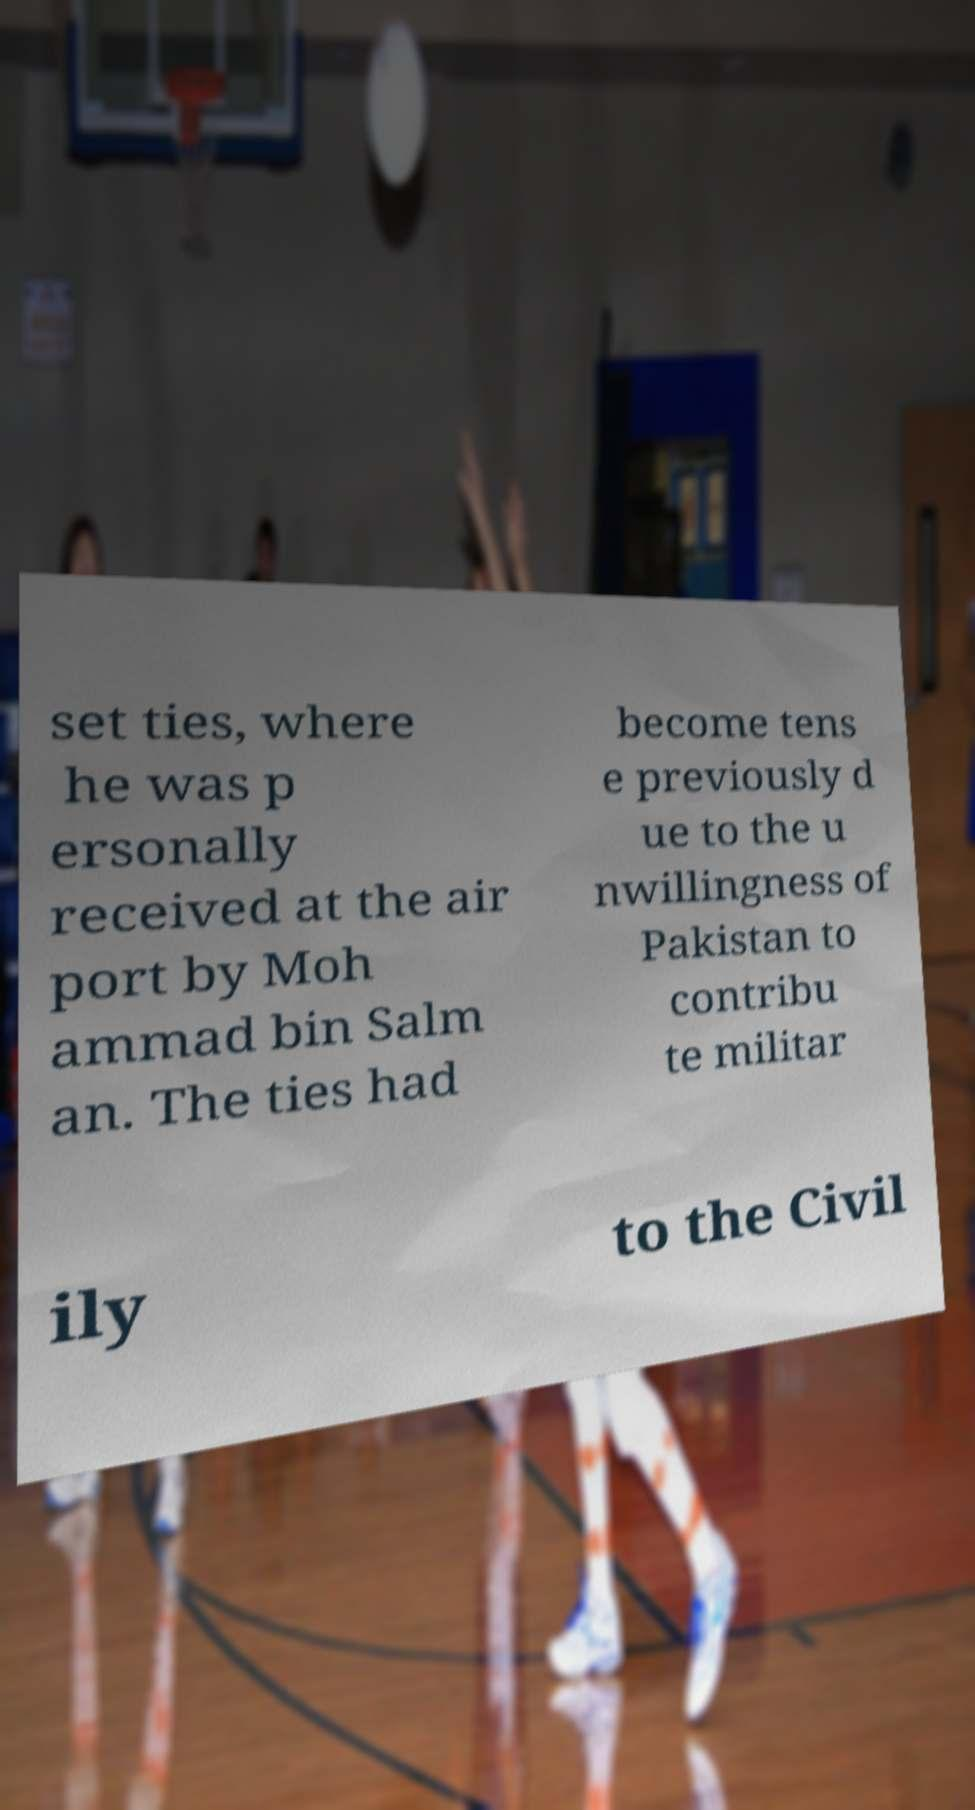Could you assist in decoding the text presented in this image and type it out clearly? set ties, where he was p ersonally received at the air port by Moh ammad bin Salm an. The ties had become tens e previously d ue to the u nwillingness of Pakistan to contribu te militar ily to the Civil 